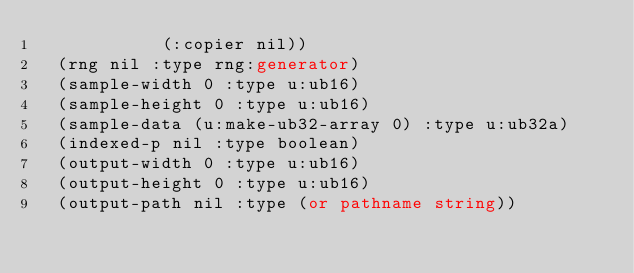Convert code to text. <code><loc_0><loc_0><loc_500><loc_500><_Lisp_>            (:copier nil))
  (rng nil :type rng:generator)
  (sample-width 0 :type u:ub16)
  (sample-height 0 :type u:ub16)
  (sample-data (u:make-ub32-array 0) :type u:ub32a)
  (indexed-p nil :type boolean)
  (output-width 0 :type u:ub16)
  (output-height 0 :type u:ub16)
  (output-path nil :type (or pathname string))</code> 